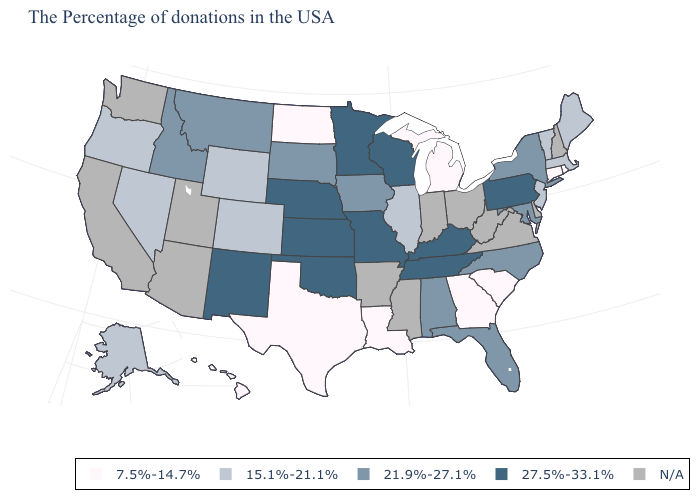Name the states that have a value in the range 7.5%-14.7%?
Be succinct. Rhode Island, Connecticut, South Carolina, Georgia, Michigan, Louisiana, Texas, North Dakota, Hawaii. What is the value of Louisiana?
Be succinct. 7.5%-14.7%. What is the value of Maryland?
Be succinct. 21.9%-27.1%. Name the states that have a value in the range 21.9%-27.1%?
Give a very brief answer. New York, Maryland, North Carolina, Florida, Alabama, Iowa, South Dakota, Montana, Idaho. Does Louisiana have the lowest value in the South?
Keep it brief. Yes. What is the lowest value in states that border New Mexico?
Be succinct. 7.5%-14.7%. What is the lowest value in the USA?
Concise answer only. 7.5%-14.7%. Among the states that border Tennessee , does Kentucky have the highest value?
Give a very brief answer. Yes. Among the states that border West Virginia , does Maryland have the highest value?
Quick response, please. No. Name the states that have a value in the range 27.5%-33.1%?
Answer briefly. Pennsylvania, Kentucky, Tennessee, Wisconsin, Missouri, Minnesota, Kansas, Nebraska, Oklahoma, New Mexico. 